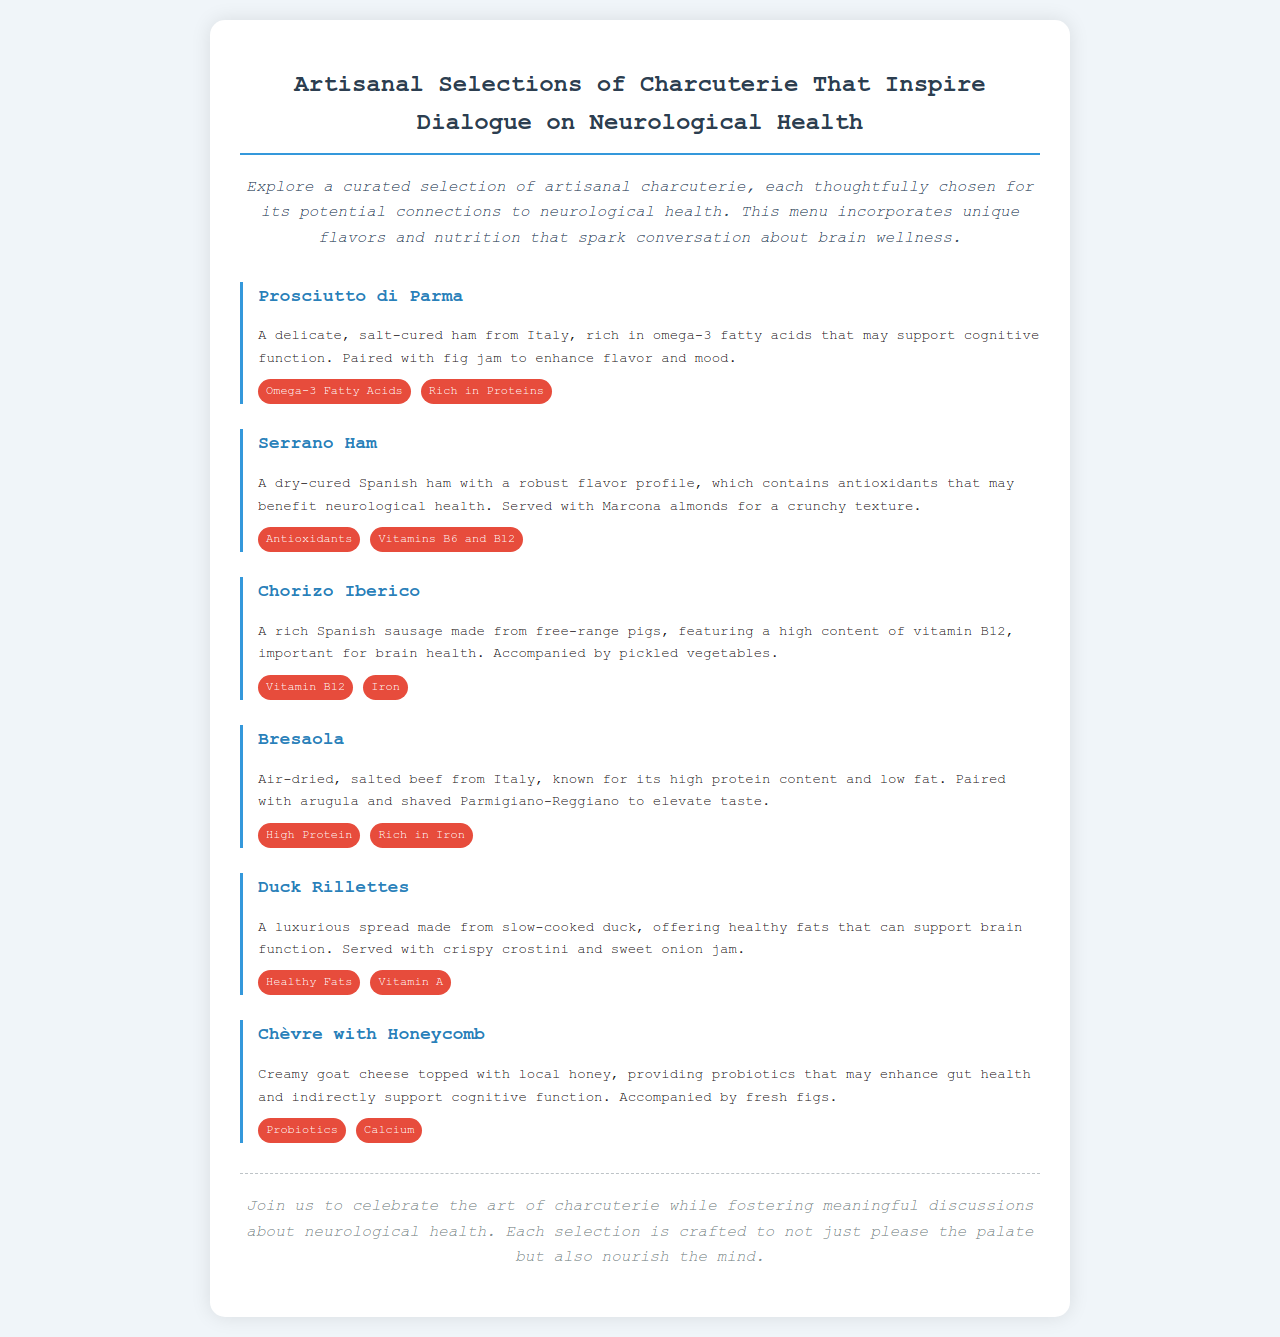What is the title of the menu? The title of the menu is prominently displayed at the top of the document.
Answer: Artisanal Selections of Charcuterie That Inspire Dialogue on Neurological Health What is the first item listed on the menu? The first menu item after the introduction is clearly indicated in the document.
Answer: Prosciutto di Parma How many health benefits are listed for Chorizo Iberico? The health benefits section for each menu item is listed immediately following the description; counting these gives the answer.
Answer: 2 What is paired with Duck Rillettes? The description of Duck Rillettes specifies what it is served with.
Answer: crispy crostini and sweet onion jam Which menu item contains probiotics? The menu item that mentions probiotics in its description is identified.
Answer: Chèvre with Honeycomb What is a distinctive feature of Serrano Ham? The description of Serrano Ham includes specific details about its flavor profile that are distinctive.
Answer: Robust flavor profile How does the menu suggest the items relate to neurological health? The introduction of the menu states the overall theme and purpose of the selections provided.
Answer: Potential connections to neurological health What type of meat is Bresaola? The description specifies the type of meat used for Bresaola.
Answer: Beef 